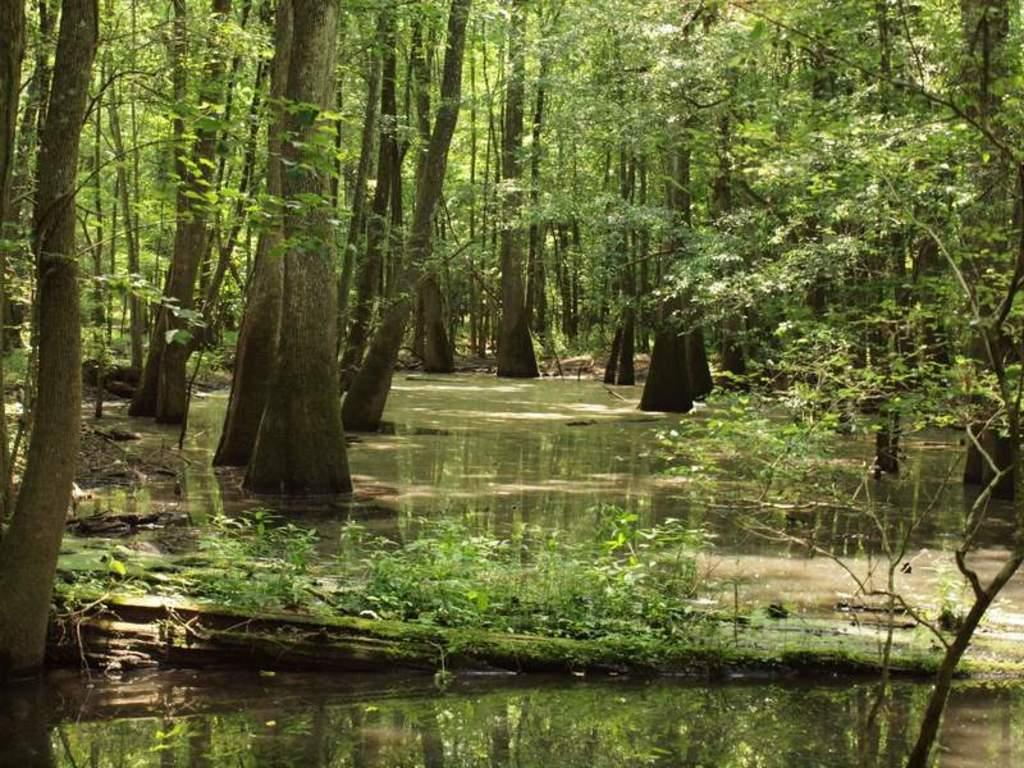What type of vegetation can be seen in the image? There are trees and plants visible in the image. What else can be seen in the image besides vegetation? There is water visible in the image. How many minutes does it take for the girls to cross the water in the image? There are no girls present in the image, so it is not possible to determine how long it would take for them to cross the water. 